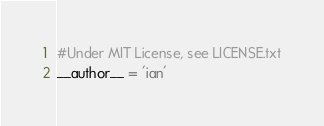<code> <loc_0><loc_0><loc_500><loc_500><_Python_>#Under MIT License, see LICENSE.txt
__author__ = 'ian'
</code> 